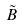<formula> <loc_0><loc_0><loc_500><loc_500>\tilde { B }</formula> 